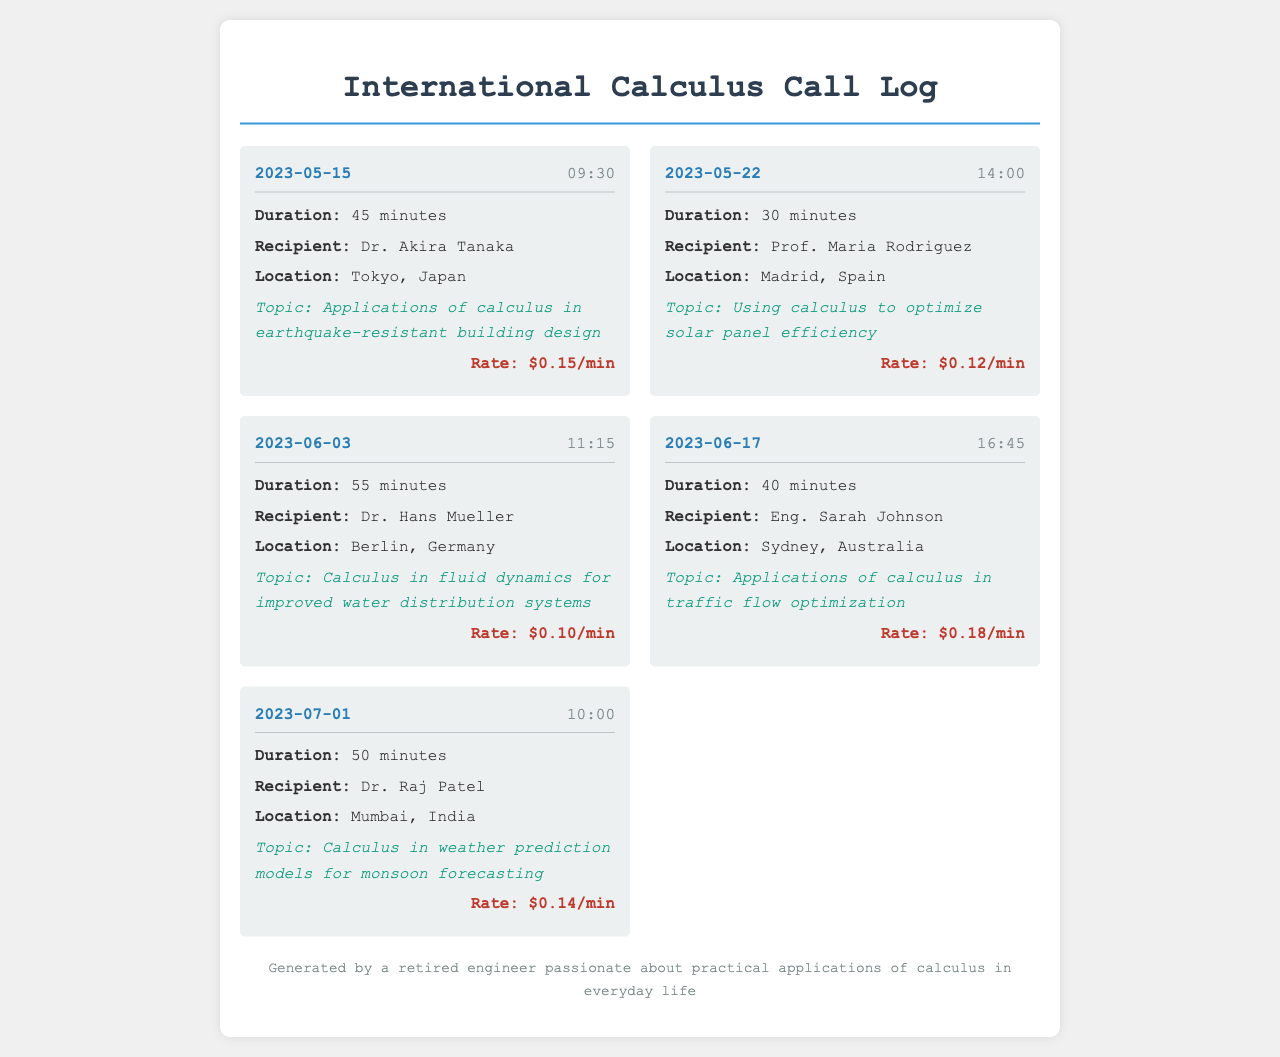What is the date of the call with Dr. Akira Tanaka? The date of the call with Dr. Akira Tanaka is provided in the call entry under the call-header section.
Answer: 2023-05-15 How long was the call with Prof. Maria Rodriguez? The duration of the call with Prof. Maria Rodriguez is listed in the call-details section.
Answer: 30 minutes What topic was discussed during the call with Dr. Hans Mueller? The topic discussed during the call with Dr. Hans Mueller is mentioned in the call-details section.
Answer: Calculus in fluid dynamics for improved water distribution systems Who is the recipient of the call on June 17th? The recipient's name for the call on June 17th is found under the call-details section.
Answer: Eng. Sarah Johnson What was the call rate for the call with Dr. Raj Patel? The call rate for the call with Dr. Raj Patel is indicated in the call-details section.
Answer: $0.14/min Which location was mentioned for the call on May 22nd? The location for the call on May 22nd is specified in the call-details section.
Answer: Madrid, Spain Which call had the highest call duration? The highest call duration can be determined by comparing the durations listed in the call-details.
Answer: 55 minutes What is the average call rate of all recorded calls? The average call rate can be calculated by taking the total rates of all calls and dividing by the number of calls.
Answer: $0.137/min What is the total duration of calls made to discuss calculus applications? The total duration is the sum of the duration of all calls in the document.
Answer: 220 minutes 